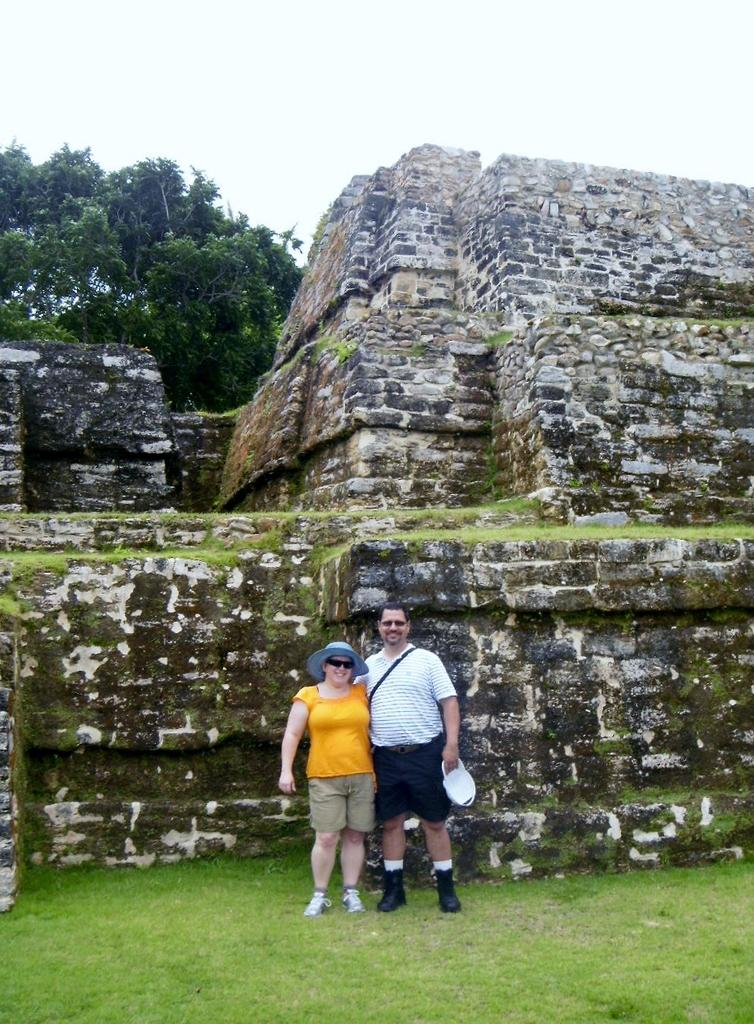What type of vegetation is present in the image? There is grass in the image. How many people are visible in the image? There are two people standing in the image. What structure can be seen in the image? There is a wall in the image. What other natural elements are present in the image? There are trees in the image. What part of the natural environment is visible in the image? The sky is visible in the image. How many boats are visible in the image? There are no boats present in the image. Is there a scarecrow standing among the trees in the image? There is no scarecrow present in the image. 